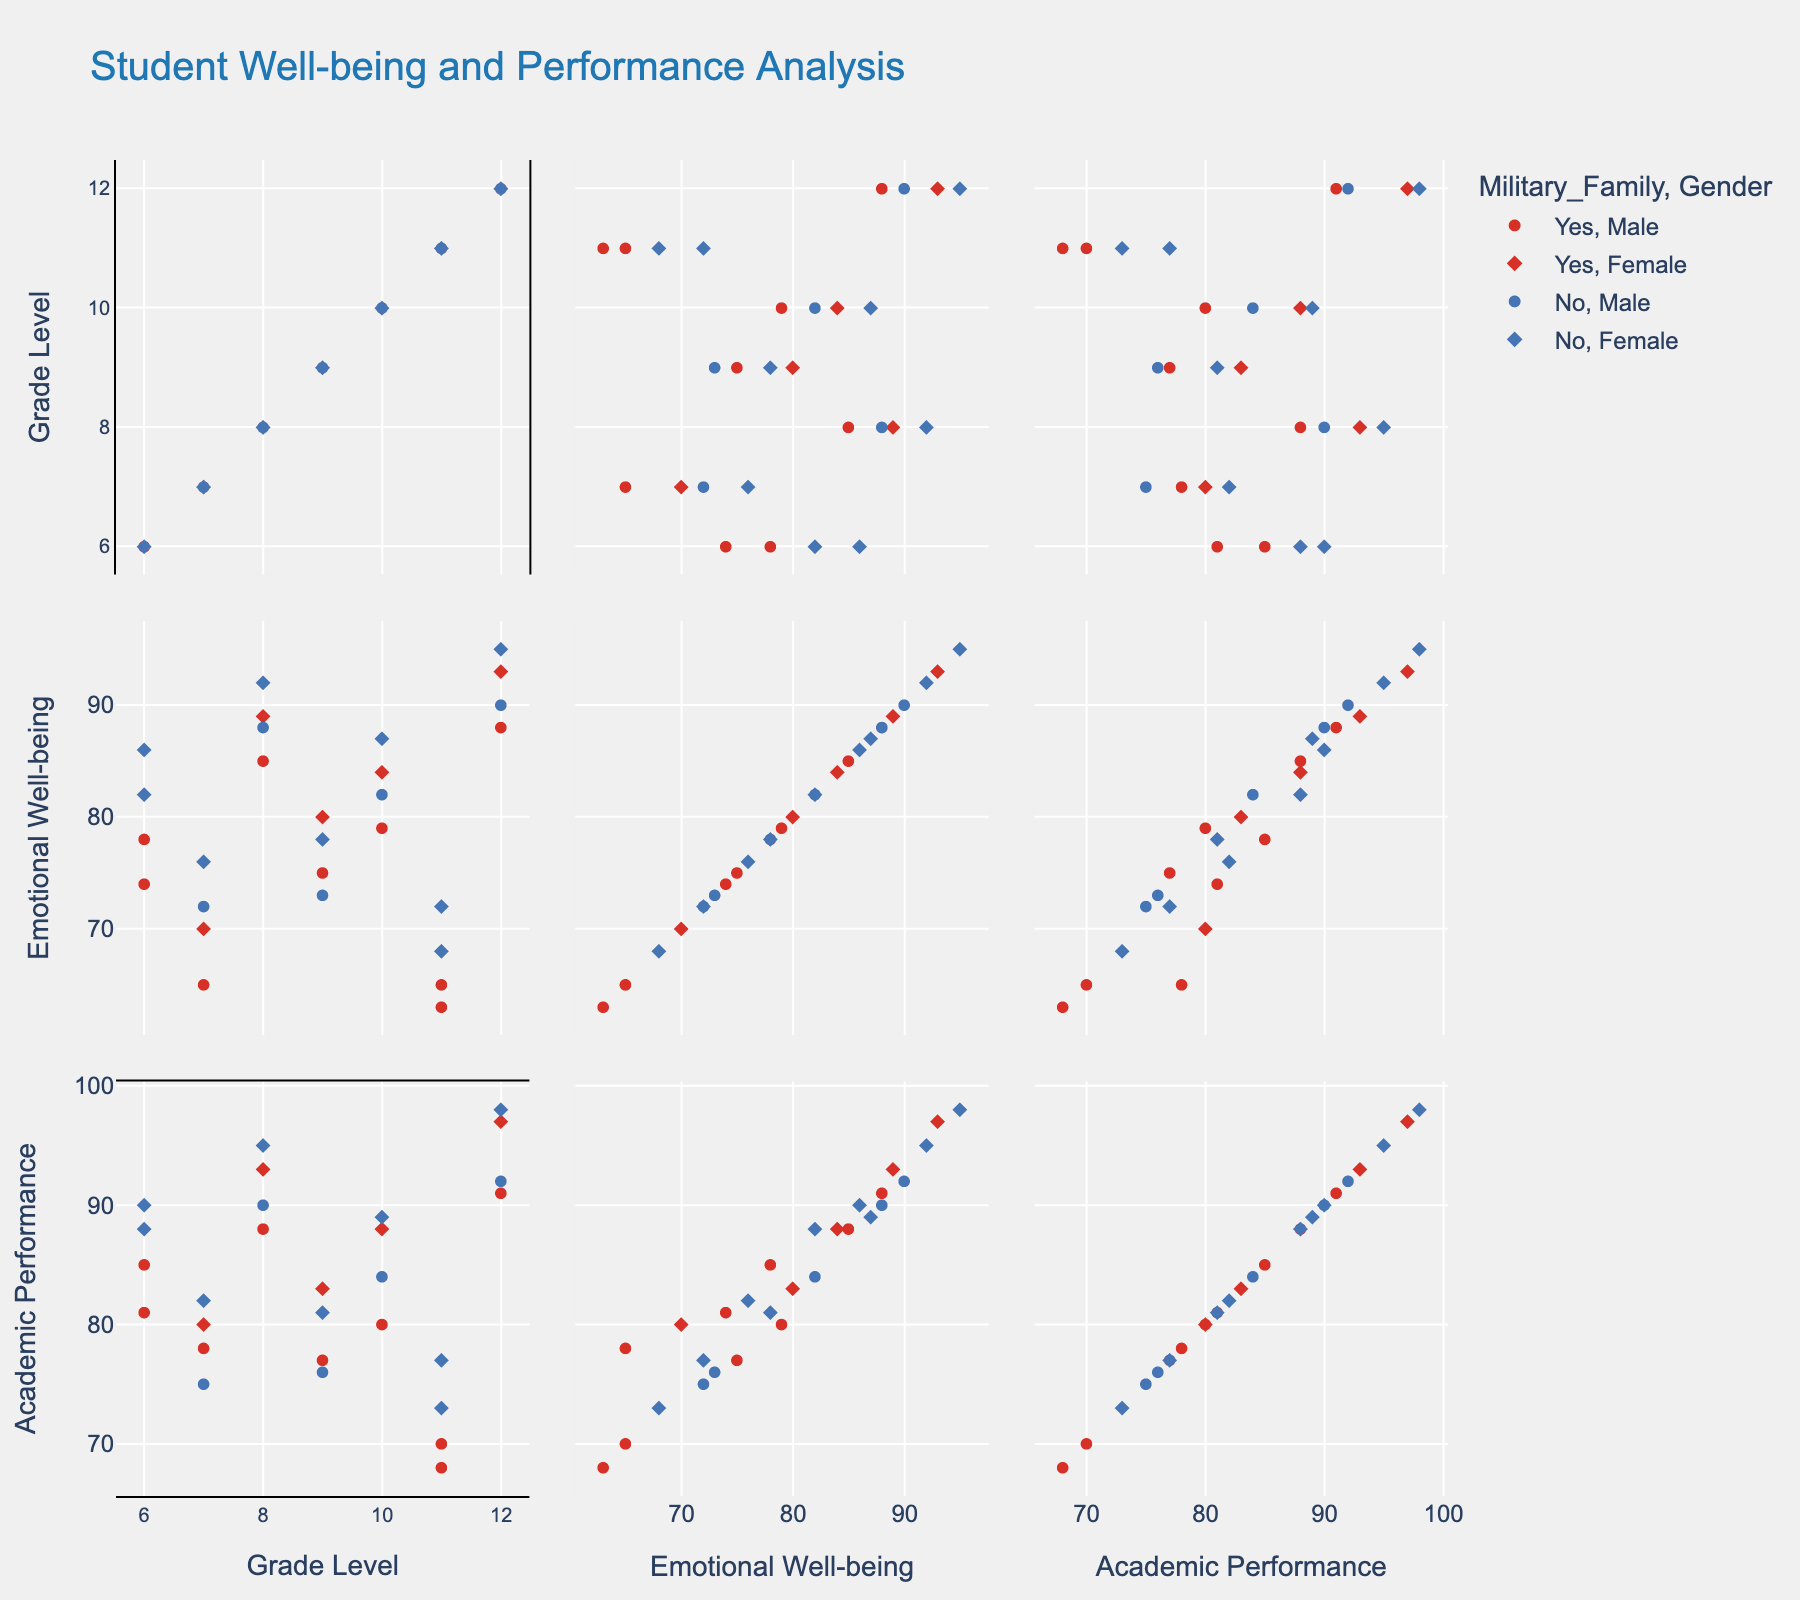What is the title of the figure? Look at the top of the figure where the title is displayed. It reads "Student Well-being and Performance Analysis".
Answer: Student Well-being and Performance Analysis Which gender symbol is represented by diamonds in the plot? By referring to the legend in the figure, the diamond shape is used to represent 'Female'.
Answer: Female How do Grade Level and Academic Performance relate in terms of clustering patterns? Examine the scatter plot matrix cells that compare 'Grade Level' and 'Academic Performance'. Look for any clustering or patterns where students with higher grade levels tend to have higher academic performance scores.
Answer: Higher grades tend to correlate with higher academic performance Are there any noticeable differences in emotional well-being scores between students from military families and non-military families? Check the color coding in the scatter plot cells that involve 'Emotional Well-being'. Compare the clustering and spread of the data points for the two colors representing 'Military Family' and 'Non-Military Family'.
Answer: Non-military family students generally have higher emotional well-being scores Which grade level shows the highest emotional well-being scores? Observe the scatter plot matrix cells involving 'Grade Level' and 'Emotional Well-being'. Identify the grade level with the highest concentration of data points towards the higher end of the emotional well-being axis.
Answer: Grade 12 Compare the academic performance of male and female students in Grade 9. Who performs better on average? Look at the scatter plot comparing 'Grade Level' with 'Academic Performance'. Filter for data points corresponding to Grade 9 and compare the academic performance scores between male and female (circle vs. diamond).
Answer: Female students in Grade 9 perform better on average How does the emotional well-being of male students compare to that of female students in Grade 8? Focus on the scatter plot cells that compare 'Grade Level' focusing on Grade 8 with 'Emotional Well-being' while distinguishing between male (circle) and female (diamond) symbols.
Answer: Female students in Grade 8 have higher emotional well-being scores What is the distribution pattern of academic performance scores for Military Family students across all grades? Examine the scatter plots related to 'Grade Level' vs. 'Academic Performance' and look at the color coding representing Military Family students. Identify the spread and clustering of these colored data points across different grades.
Answer: The scores are generally higher in upper grades but spread out Is there any visible trend in the academic performance of students from non-military families from grades 6 to 12? Check the scatter plots comparing 'Grade Level' with 'Academic Performance', focusing on the color representing non-military family students. Look for a visible trend or pattern from Grade 6 to Grade 12.
Answer: There is an increasing trend What is the pattern of emotional well-being in female students across different grades? Look at the scatter plot cells comparing 'Grade Level' with 'Emotional Well-being'. Focus on the diamond symbols which represent female students. Observe the distribution and pattern as grade levels change.
Answer: Emotional well-being improves with higher grades 